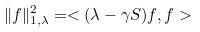Convert formula to latex. <formula><loc_0><loc_0><loc_500><loc_500>\| f \| _ { 1 , \lambda } ^ { 2 } = < ( \lambda - \gamma S ) f , f ></formula> 